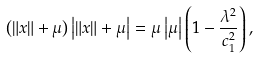<formula> <loc_0><loc_0><loc_500><loc_500>\left ( \left \| x \right \| + \mu \right ) \left | \left \| x \right \| + \mu \right | = \mu \left | \mu \right | \left ( 1 - \frac { \lambda ^ { 2 } } { c _ { 1 } ^ { 2 } } \right ) ,</formula> 